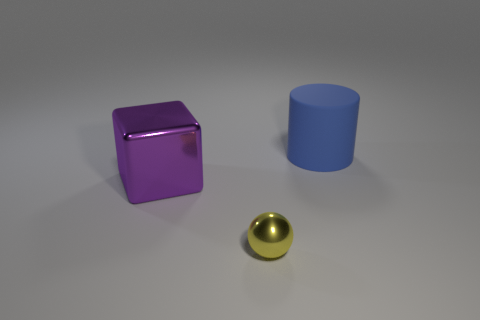There is a large blue rubber thing; are there any big objects in front of it?
Your answer should be very brief. Yes. There is a large object that is in front of the blue rubber object; is there a metal thing behind it?
Offer a terse response. No. Are there an equal number of small shiny balls that are to the right of the big blue rubber cylinder and cylinders behind the purple metal block?
Your response must be concise. No. There is a cube that is the same material as the yellow sphere; what color is it?
Offer a terse response. Purple. Are there any yellow objects that have the same material as the large purple block?
Make the answer very short. Yes. What number of things are purple shiny things or large blue things?
Provide a short and direct response. 2. Are the purple object and the object in front of the purple metallic object made of the same material?
Keep it short and to the point. Yes. There is a metallic object right of the large purple cube; what size is it?
Give a very brief answer. Small. Are there fewer big things than gray shiny cylinders?
Provide a short and direct response. No. What shape is the thing that is to the right of the big purple object and on the left side of the blue matte cylinder?
Give a very brief answer. Sphere. 